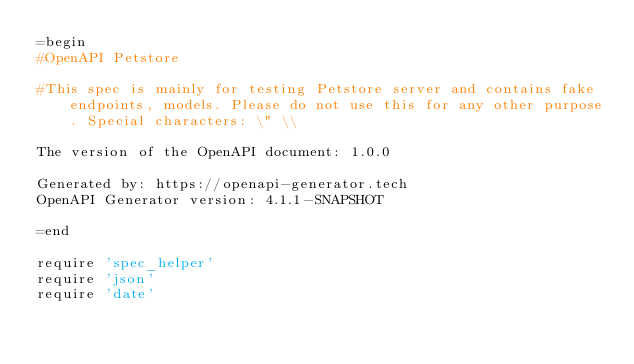Convert code to text. <code><loc_0><loc_0><loc_500><loc_500><_Ruby_>=begin
#OpenAPI Petstore

#This spec is mainly for testing Petstore server and contains fake endpoints, models. Please do not use this for any other purpose. Special characters: \" \\

The version of the OpenAPI document: 1.0.0

Generated by: https://openapi-generator.tech
OpenAPI Generator version: 4.1.1-SNAPSHOT

=end

require 'spec_helper'
require 'json'
require 'date'
</code> 